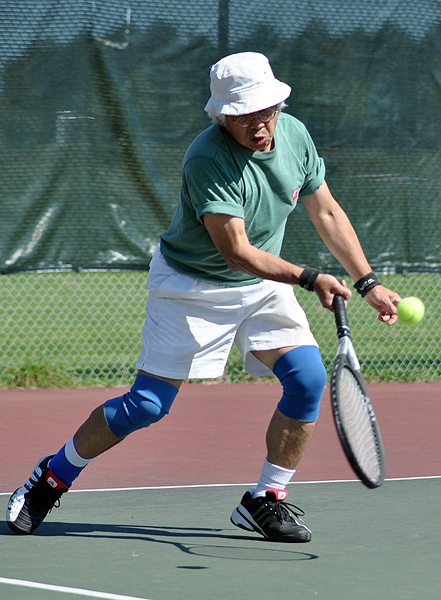Describe the objects in this image and their specific colors. I can see people in teal, black, white, gray, and darkgray tones, tennis racket in teal, lightgray, darkgray, gray, and black tones, and sports ball in teal, lightyellow, khaki, lightgreen, and olive tones in this image. 